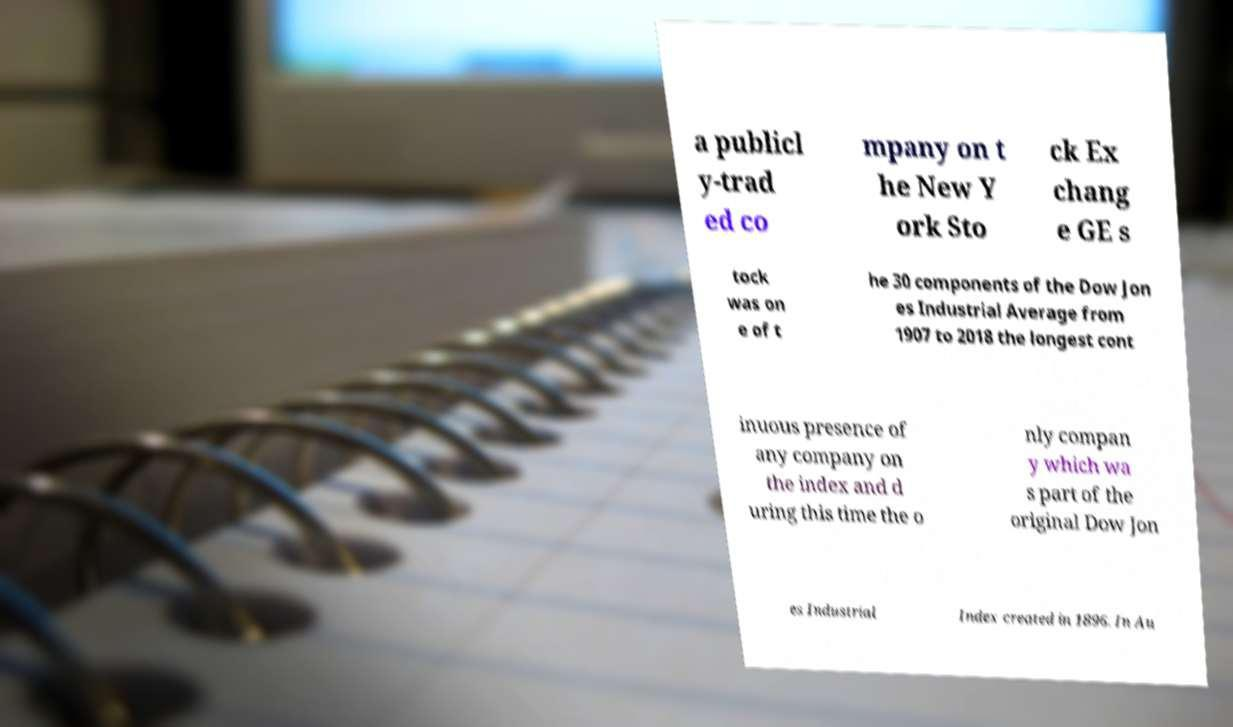Please identify and transcribe the text found in this image. a publicl y-trad ed co mpany on t he New Y ork Sto ck Ex chang e GE s tock was on e of t he 30 components of the Dow Jon es Industrial Average from 1907 to 2018 the longest cont inuous presence of any company on the index and d uring this time the o nly compan y which wa s part of the original Dow Jon es Industrial Index created in 1896. In Au 